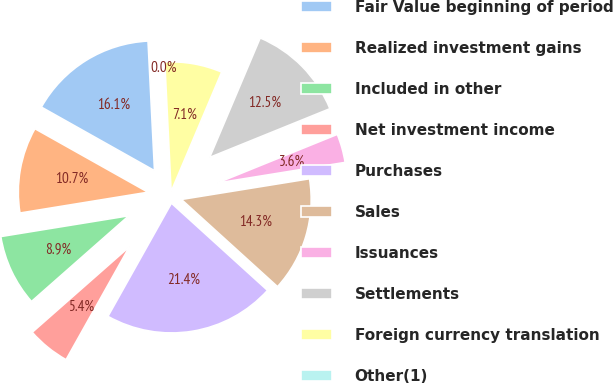Convert chart to OTSL. <chart><loc_0><loc_0><loc_500><loc_500><pie_chart><fcel>Fair Value beginning of period<fcel>Realized investment gains<fcel>Included in other<fcel>Net investment income<fcel>Purchases<fcel>Sales<fcel>Issuances<fcel>Settlements<fcel>Foreign currency translation<fcel>Other(1)<nl><fcel>16.06%<fcel>10.71%<fcel>8.93%<fcel>5.37%<fcel>21.41%<fcel>14.28%<fcel>3.58%<fcel>12.5%<fcel>7.15%<fcel>0.02%<nl></chart> 